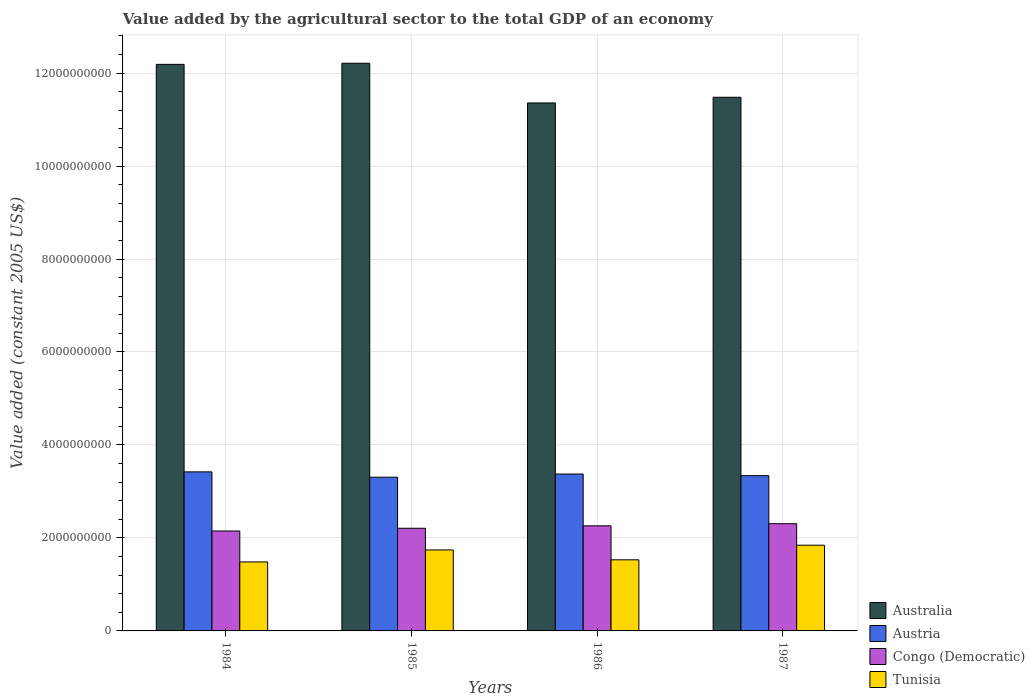How many different coloured bars are there?
Your answer should be very brief. 4. How many groups of bars are there?
Give a very brief answer. 4. Are the number of bars per tick equal to the number of legend labels?
Keep it short and to the point. Yes. Are the number of bars on each tick of the X-axis equal?
Ensure brevity in your answer.  Yes. In how many cases, is the number of bars for a given year not equal to the number of legend labels?
Provide a succinct answer. 0. What is the value added by the agricultural sector in Austria in 1987?
Provide a short and direct response. 3.34e+09. Across all years, what is the maximum value added by the agricultural sector in Australia?
Offer a terse response. 1.22e+1. Across all years, what is the minimum value added by the agricultural sector in Congo (Democratic)?
Give a very brief answer. 2.15e+09. In which year was the value added by the agricultural sector in Austria minimum?
Provide a short and direct response. 1985. What is the total value added by the agricultural sector in Australia in the graph?
Provide a short and direct response. 4.72e+1. What is the difference between the value added by the agricultural sector in Congo (Democratic) in 1985 and that in 1987?
Provide a short and direct response. -9.80e+07. What is the difference between the value added by the agricultural sector in Australia in 1986 and the value added by the agricultural sector in Austria in 1987?
Your answer should be compact. 8.02e+09. What is the average value added by the agricultural sector in Tunisia per year?
Offer a terse response. 1.65e+09. In the year 1987, what is the difference between the value added by the agricultural sector in Tunisia and value added by the agricultural sector in Australia?
Your response must be concise. -9.64e+09. In how many years, is the value added by the agricultural sector in Tunisia greater than 1200000000 US$?
Ensure brevity in your answer.  4. What is the ratio of the value added by the agricultural sector in Congo (Democratic) in 1984 to that in 1987?
Offer a terse response. 0.93. What is the difference between the highest and the second highest value added by the agricultural sector in Tunisia?
Provide a short and direct response. 1.02e+08. What is the difference between the highest and the lowest value added by the agricultural sector in Australia?
Your answer should be compact. 8.53e+08. In how many years, is the value added by the agricultural sector in Congo (Democratic) greater than the average value added by the agricultural sector in Congo (Democratic) taken over all years?
Provide a succinct answer. 2. Is it the case that in every year, the sum of the value added by the agricultural sector in Congo (Democratic) and value added by the agricultural sector in Tunisia is greater than the sum of value added by the agricultural sector in Australia and value added by the agricultural sector in Austria?
Keep it short and to the point. No. What does the 1st bar from the left in 1984 represents?
Make the answer very short. Australia. What does the 4th bar from the right in 1987 represents?
Provide a short and direct response. Australia. Is it the case that in every year, the sum of the value added by the agricultural sector in Tunisia and value added by the agricultural sector in Australia is greater than the value added by the agricultural sector in Congo (Democratic)?
Make the answer very short. Yes. How many bars are there?
Provide a succinct answer. 16. Are all the bars in the graph horizontal?
Provide a succinct answer. No. What is the difference between two consecutive major ticks on the Y-axis?
Your answer should be compact. 2.00e+09. How many legend labels are there?
Make the answer very short. 4. How are the legend labels stacked?
Ensure brevity in your answer.  Vertical. What is the title of the graph?
Keep it short and to the point. Value added by the agricultural sector to the total GDP of an economy. Does "Libya" appear as one of the legend labels in the graph?
Your answer should be compact. No. What is the label or title of the Y-axis?
Your response must be concise. Value added (constant 2005 US$). What is the Value added (constant 2005 US$) of Australia in 1984?
Ensure brevity in your answer.  1.22e+1. What is the Value added (constant 2005 US$) of Austria in 1984?
Offer a terse response. 3.42e+09. What is the Value added (constant 2005 US$) in Congo (Democratic) in 1984?
Your answer should be compact. 2.15e+09. What is the Value added (constant 2005 US$) in Tunisia in 1984?
Your answer should be very brief. 1.48e+09. What is the Value added (constant 2005 US$) of Australia in 1985?
Ensure brevity in your answer.  1.22e+1. What is the Value added (constant 2005 US$) in Austria in 1985?
Your answer should be very brief. 3.31e+09. What is the Value added (constant 2005 US$) of Congo (Democratic) in 1985?
Make the answer very short. 2.21e+09. What is the Value added (constant 2005 US$) of Tunisia in 1985?
Provide a short and direct response. 1.74e+09. What is the Value added (constant 2005 US$) of Australia in 1986?
Provide a succinct answer. 1.14e+1. What is the Value added (constant 2005 US$) in Austria in 1986?
Offer a terse response. 3.37e+09. What is the Value added (constant 2005 US$) in Congo (Democratic) in 1986?
Your response must be concise. 2.26e+09. What is the Value added (constant 2005 US$) of Tunisia in 1986?
Make the answer very short. 1.53e+09. What is the Value added (constant 2005 US$) in Australia in 1987?
Your answer should be very brief. 1.15e+1. What is the Value added (constant 2005 US$) in Austria in 1987?
Provide a short and direct response. 3.34e+09. What is the Value added (constant 2005 US$) of Congo (Democratic) in 1987?
Provide a succinct answer. 2.31e+09. What is the Value added (constant 2005 US$) of Tunisia in 1987?
Keep it short and to the point. 1.84e+09. Across all years, what is the maximum Value added (constant 2005 US$) in Australia?
Keep it short and to the point. 1.22e+1. Across all years, what is the maximum Value added (constant 2005 US$) of Austria?
Your response must be concise. 3.42e+09. Across all years, what is the maximum Value added (constant 2005 US$) of Congo (Democratic)?
Ensure brevity in your answer.  2.31e+09. Across all years, what is the maximum Value added (constant 2005 US$) of Tunisia?
Provide a short and direct response. 1.84e+09. Across all years, what is the minimum Value added (constant 2005 US$) of Australia?
Your answer should be very brief. 1.14e+1. Across all years, what is the minimum Value added (constant 2005 US$) of Austria?
Keep it short and to the point. 3.31e+09. Across all years, what is the minimum Value added (constant 2005 US$) in Congo (Democratic)?
Keep it short and to the point. 2.15e+09. Across all years, what is the minimum Value added (constant 2005 US$) of Tunisia?
Keep it short and to the point. 1.48e+09. What is the total Value added (constant 2005 US$) of Australia in the graph?
Your answer should be compact. 4.72e+1. What is the total Value added (constant 2005 US$) of Austria in the graph?
Provide a succinct answer. 1.34e+1. What is the total Value added (constant 2005 US$) of Congo (Democratic) in the graph?
Your response must be concise. 8.92e+09. What is the total Value added (constant 2005 US$) of Tunisia in the graph?
Your answer should be very brief. 6.60e+09. What is the difference between the Value added (constant 2005 US$) of Australia in 1984 and that in 1985?
Provide a short and direct response. -2.40e+07. What is the difference between the Value added (constant 2005 US$) of Austria in 1984 and that in 1985?
Keep it short and to the point. 1.15e+08. What is the difference between the Value added (constant 2005 US$) of Congo (Democratic) in 1984 and that in 1985?
Keep it short and to the point. -5.93e+07. What is the difference between the Value added (constant 2005 US$) in Tunisia in 1984 and that in 1985?
Ensure brevity in your answer.  -2.58e+08. What is the difference between the Value added (constant 2005 US$) of Australia in 1984 and that in 1986?
Keep it short and to the point. 8.29e+08. What is the difference between the Value added (constant 2005 US$) of Austria in 1984 and that in 1986?
Keep it short and to the point. 4.65e+07. What is the difference between the Value added (constant 2005 US$) in Congo (Democratic) in 1984 and that in 1986?
Keep it short and to the point. -1.11e+08. What is the difference between the Value added (constant 2005 US$) in Tunisia in 1984 and that in 1986?
Your response must be concise. -4.56e+07. What is the difference between the Value added (constant 2005 US$) of Australia in 1984 and that in 1987?
Give a very brief answer. 7.08e+08. What is the difference between the Value added (constant 2005 US$) in Austria in 1984 and that in 1987?
Provide a succinct answer. 8.17e+07. What is the difference between the Value added (constant 2005 US$) of Congo (Democratic) in 1984 and that in 1987?
Your answer should be compact. -1.57e+08. What is the difference between the Value added (constant 2005 US$) of Tunisia in 1984 and that in 1987?
Your answer should be compact. -3.60e+08. What is the difference between the Value added (constant 2005 US$) in Australia in 1985 and that in 1986?
Give a very brief answer. 8.53e+08. What is the difference between the Value added (constant 2005 US$) in Austria in 1985 and that in 1986?
Your response must be concise. -6.80e+07. What is the difference between the Value added (constant 2005 US$) of Congo (Democratic) in 1985 and that in 1986?
Keep it short and to the point. -5.20e+07. What is the difference between the Value added (constant 2005 US$) in Tunisia in 1985 and that in 1986?
Provide a succinct answer. 2.12e+08. What is the difference between the Value added (constant 2005 US$) of Australia in 1985 and that in 1987?
Your answer should be compact. 7.32e+08. What is the difference between the Value added (constant 2005 US$) in Austria in 1985 and that in 1987?
Give a very brief answer. -3.29e+07. What is the difference between the Value added (constant 2005 US$) of Congo (Democratic) in 1985 and that in 1987?
Your answer should be compact. -9.80e+07. What is the difference between the Value added (constant 2005 US$) in Tunisia in 1985 and that in 1987?
Offer a very short reply. -1.02e+08. What is the difference between the Value added (constant 2005 US$) in Australia in 1986 and that in 1987?
Offer a terse response. -1.22e+08. What is the difference between the Value added (constant 2005 US$) of Austria in 1986 and that in 1987?
Make the answer very short. 3.51e+07. What is the difference between the Value added (constant 2005 US$) of Congo (Democratic) in 1986 and that in 1987?
Your answer should be compact. -4.60e+07. What is the difference between the Value added (constant 2005 US$) in Tunisia in 1986 and that in 1987?
Provide a short and direct response. -3.14e+08. What is the difference between the Value added (constant 2005 US$) in Australia in 1984 and the Value added (constant 2005 US$) in Austria in 1985?
Keep it short and to the point. 8.88e+09. What is the difference between the Value added (constant 2005 US$) in Australia in 1984 and the Value added (constant 2005 US$) in Congo (Democratic) in 1985?
Keep it short and to the point. 9.98e+09. What is the difference between the Value added (constant 2005 US$) in Australia in 1984 and the Value added (constant 2005 US$) in Tunisia in 1985?
Offer a very short reply. 1.04e+1. What is the difference between the Value added (constant 2005 US$) of Austria in 1984 and the Value added (constant 2005 US$) of Congo (Democratic) in 1985?
Your answer should be very brief. 1.21e+09. What is the difference between the Value added (constant 2005 US$) in Austria in 1984 and the Value added (constant 2005 US$) in Tunisia in 1985?
Ensure brevity in your answer.  1.68e+09. What is the difference between the Value added (constant 2005 US$) in Congo (Democratic) in 1984 and the Value added (constant 2005 US$) in Tunisia in 1985?
Your answer should be compact. 4.07e+08. What is the difference between the Value added (constant 2005 US$) in Australia in 1984 and the Value added (constant 2005 US$) in Austria in 1986?
Your answer should be very brief. 8.81e+09. What is the difference between the Value added (constant 2005 US$) of Australia in 1984 and the Value added (constant 2005 US$) of Congo (Democratic) in 1986?
Your answer should be compact. 9.93e+09. What is the difference between the Value added (constant 2005 US$) of Australia in 1984 and the Value added (constant 2005 US$) of Tunisia in 1986?
Your answer should be compact. 1.07e+1. What is the difference between the Value added (constant 2005 US$) of Austria in 1984 and the Value added (constant 2005 US$) of Congo (Democratic) in 1986?
Ensure brevity in your answer.  1.16e+09. What is the difference between the Value added (constant 2005 US$) of Austria in 1984 and the Value added (constant 2005 US$) of Tunisia in 1986?
Make the answer very short. 1.89e+09. What is the difference between the Value added (constant 2005 US$) in Congo (Democratic) in 1984 and the Value added (constant 2005 US$) in Tunisia in 1986?
Provide a succinct answer. 6.19e+08. What is the difference between the Value added (constant 2005 US$) of Australia in 1984 and the Value added (constant 2005 US$) of Austria in 1987?
Keep it short and to the point. 8.85e+09. What is the difference between the Value added (constant 2005 US$) of Australia in 1984 and the Value added (constant 2005 US$) of Congo (Democratic) in 1987?
Give a very brief answer. 9.88e+09. What is the difference between the Value added (constant 2005 US$) of Australia in 1984 and the Value added (constant 2005 US$) of Tunisia in 1987?
Offer a terse response. 1.03e+1. What is the difference between the Value added (constant 2005 US$) in Austria in 1984 and the Value added (constant 2005 US$) in Congo (Democratic) in 1987?
Offer a very short reply. 1.11e+09. What is the difference between the Value added (constant 2005 US$) of Austria in 1984 and the Value added (constant 2005 US$) of Tunisia in 1987?
Provide a short and direct response. 1.58e+09. What is the difference between the Value added (constant 2005 US$) in Congo (Democratic) in 1984 and the Value added (constant 2005 US$) in Tunisia in 1987?
Provide a succinct answer. 3.05e+08. What is the difference between the Value added (constant 2005 US$) in Australia in 1985 and the Value added (constant 2005 US$) in Austria in 1986?
Your answer should be very brief. 8.84e+09. What is the difference between the Value added (constant 2005 US$) of Australia in 1985 and the Value added (constant 2005 US$) of Congo (Democratic) in 1986?
Offer a terse response. 9.95e+09. What is the difference between the Value added (constant 2005 US$) of Australia in 1985 and the Value added (constant 2005 US$) of Tunisia in 1986?
Provide a short and direct response. 1.07e+1. What is the difference between the Value added (constant 2005 US$) of Austria in 1985 and the Value added (constant 2005 US$) of Congo (Democratic) in 1986?
Give a very brief answer. 1.05e+09. What is the difference between the Value added (constant 2005 US$) in Austria in 1985 and the Value added (constant 2005 US$) in Tunisia in 1986?
Give a very brief answer. 1.78e+09. What is the difference between the Value added (constant 2005 US$) of Congo (Democratic) in 1985 and the Value added (constant 2005 US$) of Tunisia in 1986?
Offer a very short reply. 6.79e+08. What is the difference between the Value added (constant 2005 US$) in Australia in 1985 and the Value added (constant 2005 US$) in Austria in 1987?
Give a very brief answer. 8.87e+09. What is the difference between the Value added (constant 2005 US$) in Australia in 1985 and the Value added (constant 2005 US$) in Congo (Democratic) in 1987?
Offer a very short reply. 9.90e+09. What is the difference between the Value added (constant 2005 US$) of Australia in 1985 and the Value added (constant 2005 US$) of Tunisia in 1987?
Keep it short and to the point. 1.04e+1. What is the difference between the Value added (constant 2005 US$) in Austria in 1985 and the Value added (constant 2005 US$) in Congo (Democratic) in 1987?
Your response must be concise. 1.00e+09. What is the difference between the Value added (constant 2005 US$) in Austria in 1985 and the Value added (constant 2005 US$) in Tunisia in 1987?
Provide a short and direct response. 1.46e+09. What is the difference between the Value added (constant 2005 US$) of Congo (Democratic) in 1985 and the Value added (constant 2005 US$) of Tunisia in 1987?
Provide a short and direct response. 3.65e+08. What is the difference between the Value added (constant 2005 US$) in Australia in 1986 and the Value added (constant 2005 US$) in Austria in 1987?
Give a very brief answer. 8.02e+09. What is the difference between the Value added (constant 2005 US$) of Australia in 1986 and the Value added (constant 2005 US$) of Congo (Democratic) in 1987?
Provide a short and direct response. 9.05e+09. What is the difference between the Value added (constant 2005 US$) of Australia in 1986 and the Value added (constant 2005 US$) of Tunisia in 1987?
Ensure brevity in your answer.  9.51e+09. What is the difference between the Value added (constant 2005 US$) of Austria in 1986 and the Value added (constant 2005 US$) of Congo (Democratic) in 1987?
Your answer should be compact. 1.07e+09. What is the difference between the Value added (constant 2005 US$) in Austria in 1986 and the Value added (constant 2005 US$) in Tunisia in 1987?
Keep it short and to the point. 1.53e+09. What is the difference between the Value added (constant 2005 US$) in Congo (Democratic) in 1986 and the Value added (constant 2005 US$) in Tunisia in 1987?
Your response must be concise. 4.17e+08. What is the average Value added (constant 2005 US$) in Australia per year?
Your answer should be very brief. 1.18e+1. What is the average Value added (constant 2005 US$) of Austria per year?
Keep it short and to the point. 3.36e+09. What is the average Value added (constant 2005 US$) of Congo (Democratic) per year?
Your response must be concise. 2.23e+09. What is the average Value added (constant 2005 US$) of Tunisia per year?
Offer a very short reply. 1.65e+09. In the year 1984, what is the difference between the Value added (constant 2005 US$) in Australia and Value added (constant 2005 US$) in Austria?
Your answer should be very brief. 8.77e+09. In the year 1984, what is the difference between the Value added (constant 2005 US$) in Australia and Value added (constant 2005 US$) in Congo (Democratic)?
Offer a terse response. 1.00e+1. In the year 1984, what is the difference between the Value added (constant 2005 US$) in Australia and Value added (constant 2005 US$) in Tunisia?
Keep it short and to the point. 1.07e+1. In the year 1984, what is the difference between the Value added (constant 2005 US$) in Austria and Value added (constant 2005 US$) in Congo (Democratic)?
Make the answer very short. 1.27e+09. In the year 1984, what is the difference between the Value added (constant 2005 US$) in Austria and Value added (constant 2005 US$) in Tunisia?
Your response must be concise. 1.94e+09. In the year 1984, what is the difference between the Value added (constant 2005 US$) in Congo (Democratic) and Value added (constant 2005 US$) in Tunisia?
Provide a succinct answer. 6.65e+08. In the year 1985, what is the difference between the Value added (constant 2005 US$) in Australia and Value added (constant 2005 US$) in Austria?
Provide a succinct answer. 8.90e+09. In the year 1985, what is the difference between the Value added (constant 2005 US$) in Australia and Value added (constant 2005 US$) in Congo (Democratic)?
Make the answer very short. 1.00e+1. In the year 1985, what is the difference between the Value added (constant 2005 US$) of Australia and Value added (constant 2005 US$) of Tunisia?
Your answer should be very brief. 1.05e+1. In the year 1985, what is the difference between the Value added (constant 2005 US$) of Austria and Value added (constant 2005 US$) of Congo (Democratic)?
Give a very brief answer. 1.10e+09. In the year 1985, what is the difference between the Value added (constant 2005 US$) of Austria and Value added (constant 2005 US$) of Tunisia?
Your response must be concise. 1.57e+09. In the year 1985, what is the difference between the Value added (constant 2005 US$) in Congo (Democratic) and Value added (constant 2005 US$) in Tunisia?
Provide a succinct answer. 4.67e+08. In the year 1986, what is the difference between the Value added (constant 2005 US$) of Australia and Value added (constant 2005 US$) of Austria?
Give a very brief answer. 7.98e+09. In the year 1986, what is the difference between the Value added (constant 2005 US$) of Australia and Value added (constant 2005 US$) of Congo (Democratic)?
Offer a terse response. 9.10e+09. In the year 1986, what is the difference between the Value added (constant 2005 US$) of Australia and Value added (constant 2005 US$) of Tunisia?
Offer a very short reply. 9.83e+09. In the year 1986, what is the difference between the Value added (constant 2005 US$) in Austria and Value added (constant 2005 US$) in Congo (Democratic)?
Offer a very short reply. 1.11e+09. In the year 1986, what is the difference between the Value added (constant 2005 US$) in Austria and Value added (constant 2005 US$) in Tunisia?
Ensure brevity in your answer.  1.85e+09. In the year 1986, what is the difference between the Value added (constant 2005 US$) of Congo (Democratic) and Value added (constant 2005 US$) of Tunisia?
Keep it short and to the point. 7.31e+08. In the year 1987, what is the difference between the Value added (constant 2005 US$) in Australia and Value added (constant 2005 US$) in Austria?
Offer a very short reply. 8.14e+09. In the year 1987, what is the difference between the Value added (constant 2005 US$) of Australia and Value added (constant 2005 US$) of Congo (Democratic)?
Provide a succinct answer. 9.17e+09. In the year 1987, what is the difference between the Value added (constant 2005 US$) of Australia and Value added (constant 2005 US$) of Tunisia?
Your answer should be compact. 9.64e+09. In the year 1987, what is the difference between the Value added (constant 2005 US$) in Austria and Value added (constant 2005 US$) in Congo (Democratic)?
Provide a succinct answer. 1.03e+09. In the year 1987, what is the difference between the Value added (constant 2005 US$) in Austria and Value added (constant 2005 US$) in Tunisia?
Ensure brevity in your answer.  1.50e+09. In the year 1987, what is the difference between the Value added (constant 2005 US$) in Congo (Democratic) and Value added (constant 2005 US$) in Tunisia?
Provide a succinct answer. 4.63e+08. What is the ratio of the Value added (constant 2005 US$) in Austria in 1984 to that in 1985?
Provide a succinct answer. 1.03. What is the ratio of the Value added (constant 2005 US$) in Congo (Democratic) in 1984 to that in 1985?
Your answer should be very brief. 0.97. What is the ratio of the Value added (constant 2005 US$) of Tunisia in 1984 to that in 1985?
Provide a short and direct response. 0.85. What is the ratio of the Value added (constant 2005 US$) of Australia in 1984 to that in 1986?
Provide a succinct answer. 1.07. What is the ratio of the Value added (constant 2005 US$) of Austria in 1984 to that in 1986?
Keep it short and to the point. 1.01. What is the ratio of the Value added (constant 2005 US$) of Congo (Democratic) in 1984 to that in 1986?
Offer a very short reply. 0.95. What is the ratio of the Value added (constant 2005 US$) in Tunisia in 1984 to that in 1986?
Your answer should be compact. 0.97. What is the ratio of the Value added (constant 2005 US$) in Australia in 1984 to that in 1987?
Offer a very short reply. 1.06. What is the ratio of the Value added (constant 2005 US$) in Austria in 1984 to that in 1987?
Make the answer very short. 1.02. What is the ratio of the Value added (constant 2005 US$) of Congo (Democratic) in 1984 to that in 1987?
Ensure brevity in your answer.  0.93. What is the ratio of the Value added (constant 2005 US$) in Tunisia in 1984 to that in 1987?
Give a very brief answer. 0.8. What is the ratio of the Value added (constant 2005 US$) in Australia in 1985 to that in 1986?
Provide a succinct answer. 1.08. What is the ratio of the Value added (constant 2005 US$) in Austria in 1985 to that in 1986?
Your answer should be compact. 0.98. What is the ratio of the Value added (constant 2005 US$) in Congo (Democratic) in 1985 to that in 1986?
Offer a terse response. 0.98. What is the ratio of the Value added (constant 2005 US$) in Tunisia in 1985 to that in 1986?
Give a very brief answer. 1.14. What is the ratio of the Value added (constant 2005 US$) in Australia in 1985 to that in 1987?
Provide a succinct answer. 1.06. What is the ratio of the Value added (constant 2005 US$) of Austria in 1985 to that in 1987?
Make the answer very short. 0.99. What is the ratio of the Value added (constant 2005 US$) of Congo (Democratic) in 1985 to that in 1987?
Offer a terse response. 0.96. What is the ratio of the Value added (constant 2005 US$) in Tunisia in 1985 to that in 1987?
Offer a terse response. 0.94. What is the ratio of the Value added (constant 2005 US$) of Austria in 1986 to that in 1987?
Provide a short and direct response. 1.01. What is the ratio of the Value added (constant 2005 US$) of Congo (Democratic) in 1986 to that in 1987?
Give a very brief answer. 0.98. What is the ratio of the Value added (constant 2005 US$) in Tunisia in 1986 to that in 1987?
Ensure brevity in your answer.  0.83. What is the difference between the highest and the second highest Value added (constant 2005 US$) in Australia?
Ensure brevity in your answer.  2.40e+07. What is the difference between the highest and the second highest Value added (constant 2005 US$) in Austria?
Your answer should be compact. 4.65e+07. What is the difference between the highest and the second highest Value added (constant 2005 US$) of Congo (Democratic)?
Ensure brevity in your answer.  4.60e+07. What is the difference between the highest and the second highest Value added (constant 2005 US$) in Tunisia?
Your response must be concise. 1.02e+08. What is the difference between the highest and the lowest Value added (constant 2005 US$) of Australia?
Provide a short and direct response. 8.53e+08. What is the difference between the highest and the lowest Value added (constant 2005 US$) of Austria?
Keep it short and to the point. 1.15e+08. What is the difference between the highest and the lowest Value added (constant 2005 US$) in Congo (Democratic)?
Make the answer very short. 1.57e+08. What is the difference between the highest and the lowest Value added (constant 2005 US$) in Tunisia?
Your answer should be compact. 3.60e+08. 